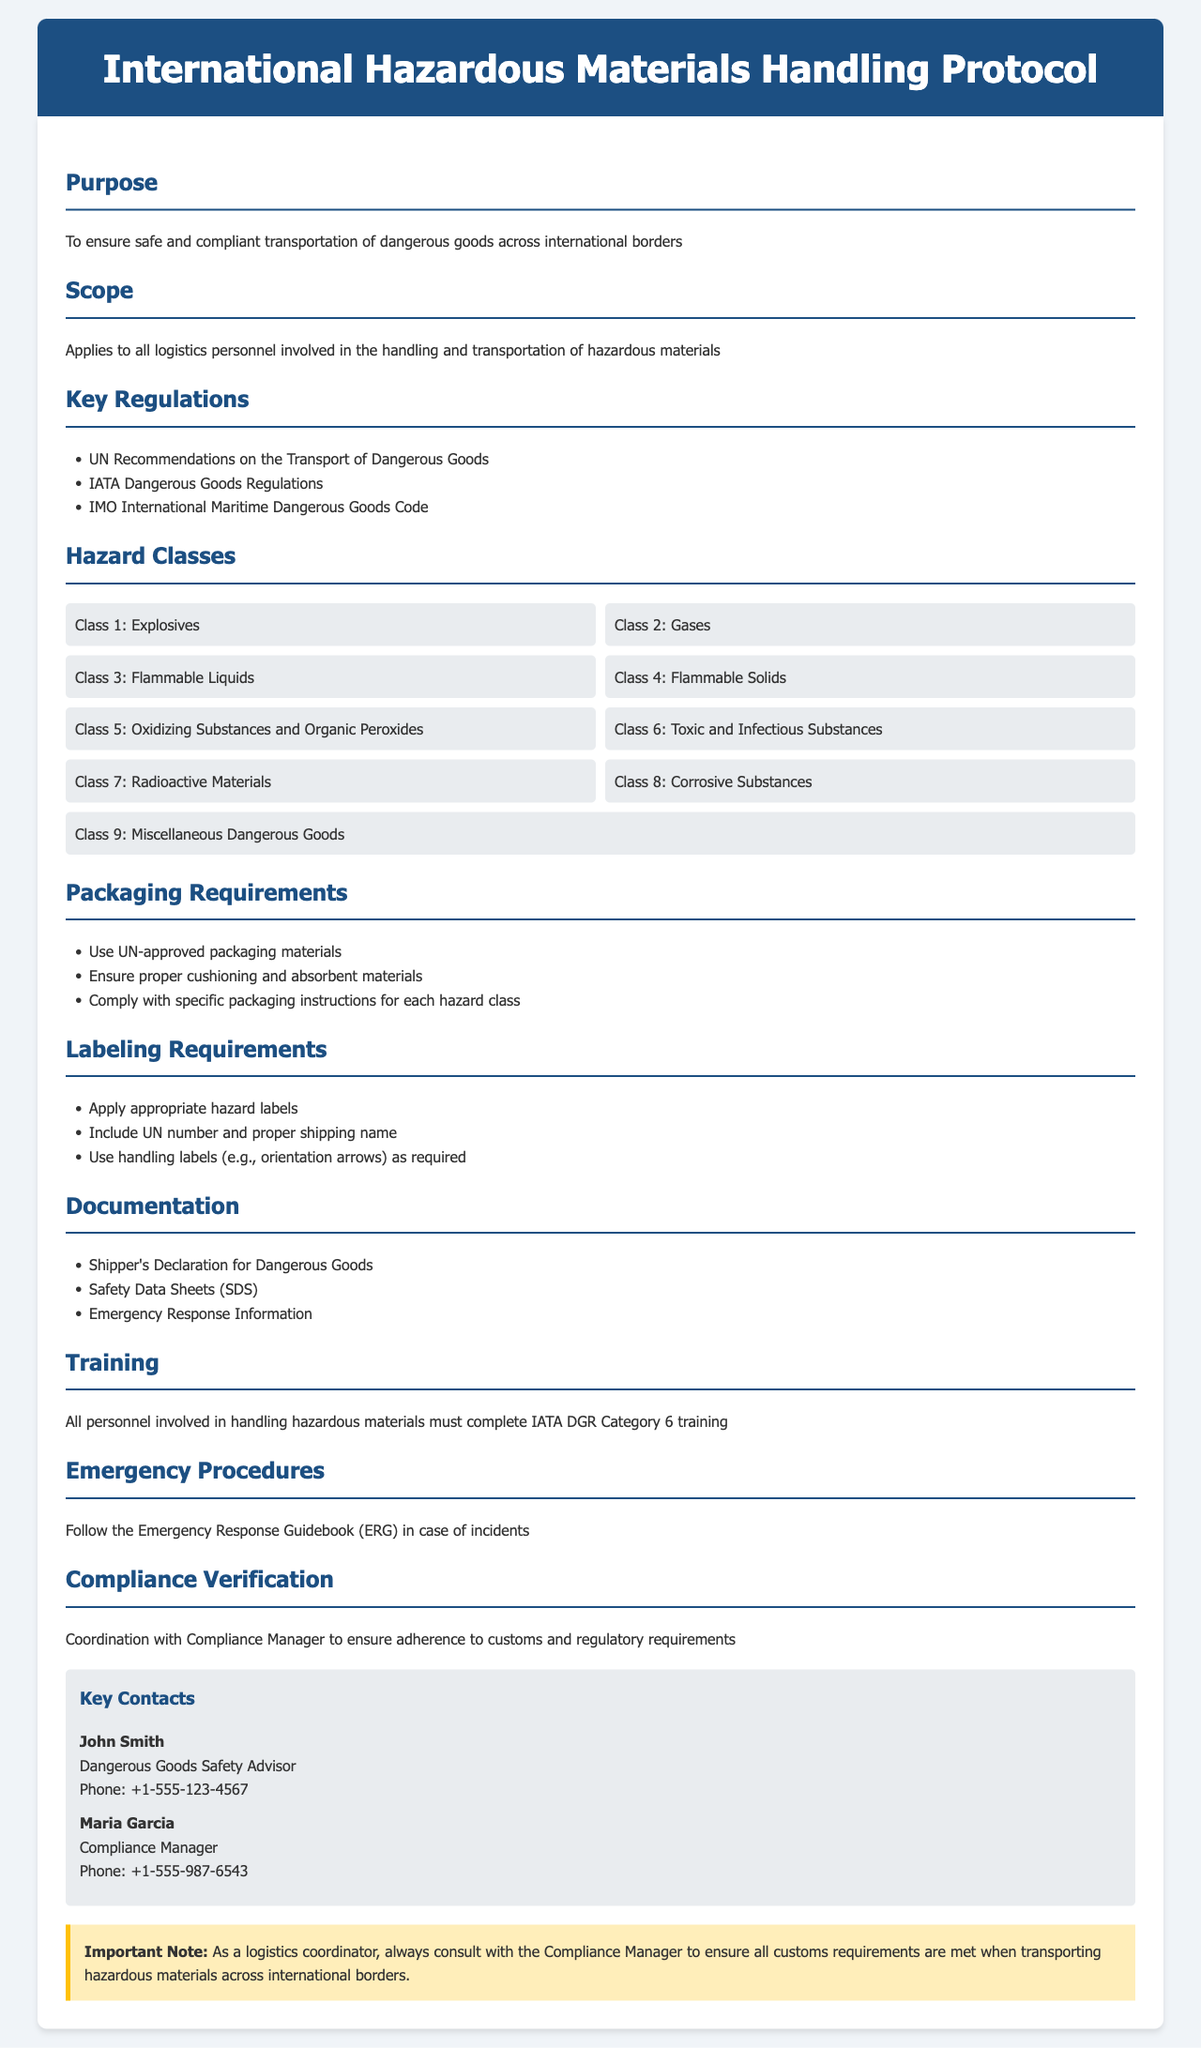What is the purpose of the document? The purpose is stated in the introduction, focusing on safe and compliant transportation of dangerous goods.
Answer: To ensure safe and compliant transportation of dangerous goods across international borders What classes of hazardous materials are mentioned? The document lists several classes of hazardous materials under the Hazard Classes heading.
Answer: Class 1: Explosives, Class 2: Gases, Class 3: Flammable Liquids, Class 4: Flammable Solids, Class 5: Oxidizing Substances and Organic Peroxides, Class 6: Toxic and Infectious Substances, Class 7: Radioactive Materials, Class 8: Corrosive Substances, Class 9: Miscellaneous Dangerous Goods What is required for packaging? The document specifies what is necessary for packaging under the Packaging Requirements section.
Answer: Use UN-approved packaging materials What training must personnel complete? The training requirement for personnel is described under the Training section of the document.
Answer: IATA DGR Category 6 training Who is the Compliance Manager? The contact information section provides the name and role of the Compliance Manager.
Answer: Maria Garcia What document is needed for hazardous goods? The documentation section lists essential documents required for handling hazardous materials.
Answer: Shipper's Declaration for Dangerous Goods What emergency procedure guide is mentioned? The Emergency Procedures section refers to a specific guide that should be followed in case of incidents.
Answer: Emergency Response Guidebook (ERG) What is the key regulatory standard mentioned? The Key Regulations section identifies important regulations related to hazardous materials transport.
Answer: UN Recommendations on the Transport of Dangerous Goods Who is the Dangerous Goods Safety Advisor? The contact details section lists the Dangerous Goods Safety Advisor's name.
Answer: John Smith 